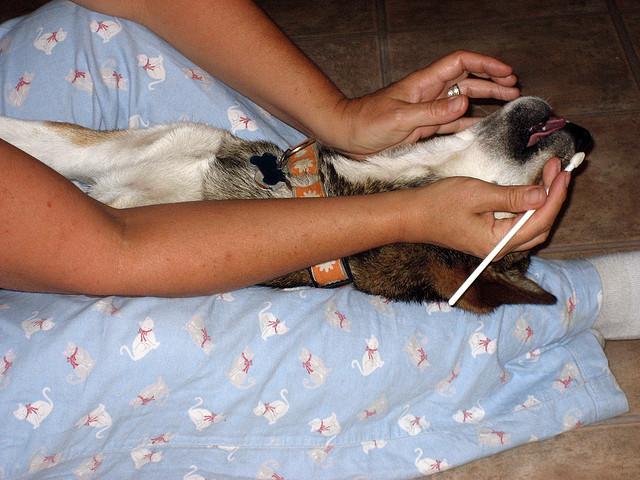Is the person wearing dress clothes?
Answer briefly. No. What color is the dog's collar?
Answer briefly. Orange. Are the dog's teeth being cleaned?
Write a very short answer. Yes. 